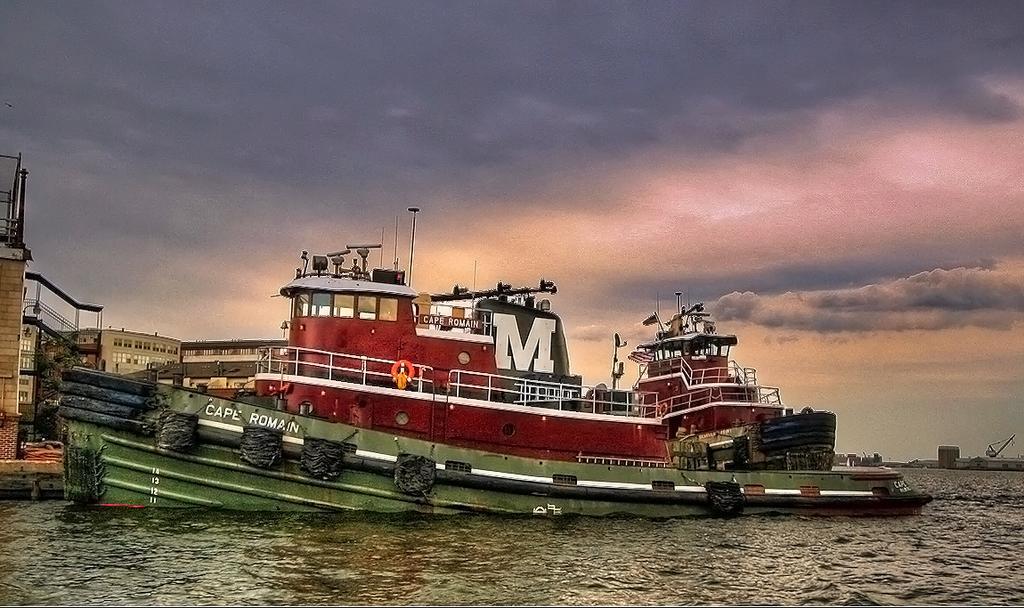How would you summarize this image in a sentence or two? In this picture I can see the water on which there are 2 ships and I see something is written on the left ship. In the background I can see the buildings and the sky which is a bit cloudy. 